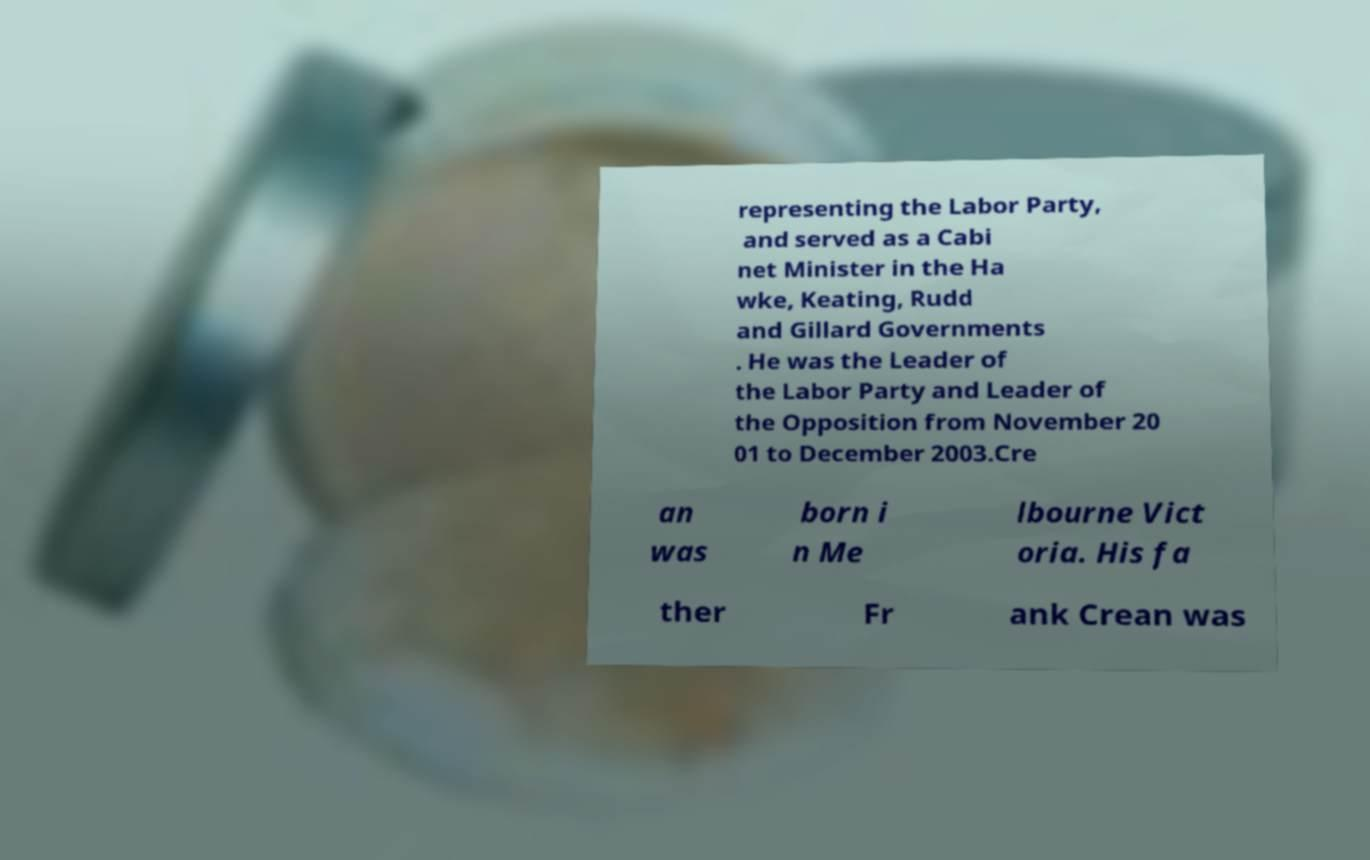Can you read and provide the text displayed in the image?This photo seems to have some interesting text. Can you extract and type it out for me? representing the Labor Party, and served as a Cabi net Minister in the Ha wke, Keating, Rudd and Gillard Governments . He was the Leader of the Labor Party and Leader of the Opposition from November 20 01 to December 2003.Cre an was born i n Me lbourne Vict oria. His fa ther Fr ank Crean was 